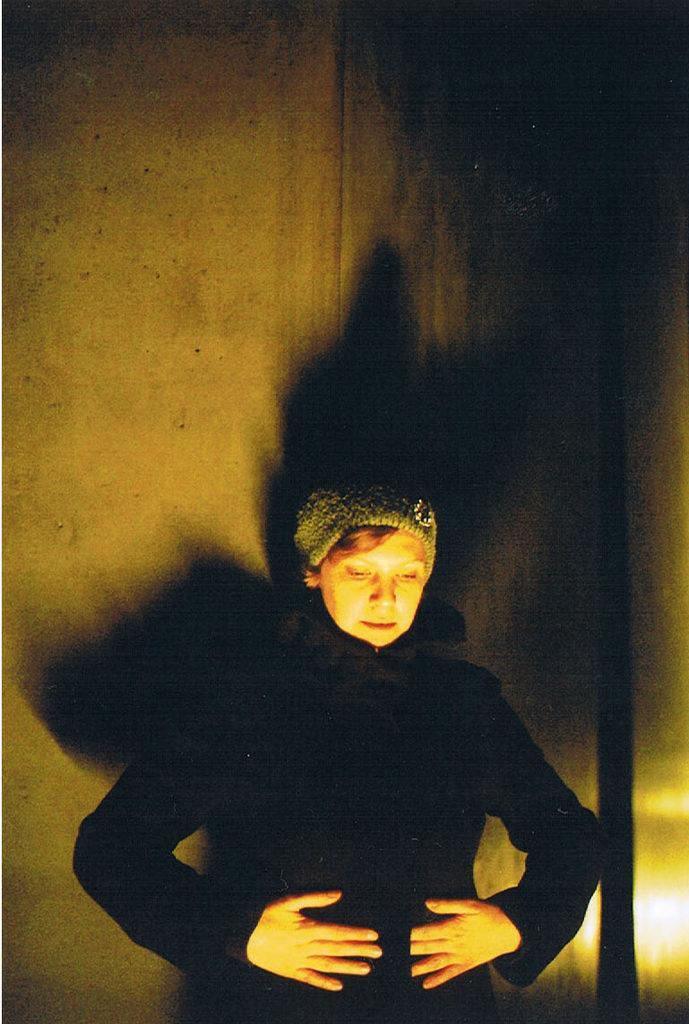How would you summarize this image in a sentence or two? This picture shows a woman with a cap on her head and she wore a black coat. We see wall on the back. 